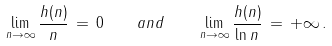Convert formula to latex. <formula><loc_0><loc_0><loc_500><loc_500>\lim _ { n \rightarrow \infty } \frac { h ( n ) } { n } \, = \, 0 \quad a n d \quad \lim _ { n \rightarrow \infty } \frac { h ( n ) } { \ln n } \, = \, + \infty \, .</formula> 